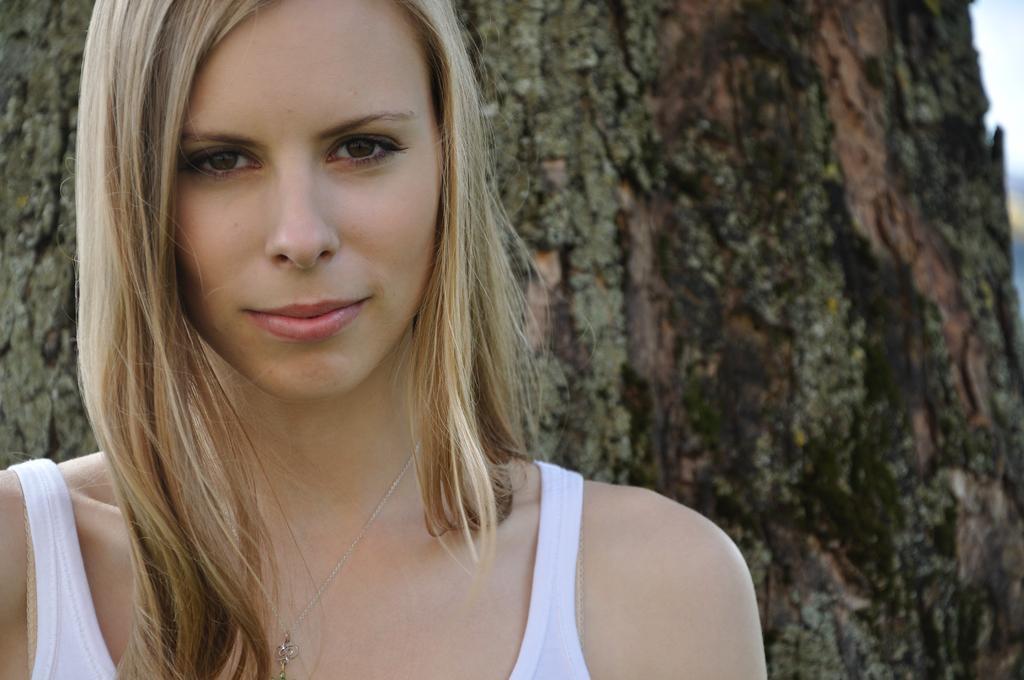Please provide a concise description of this image. This image is taken outdoors. In the background there is a tree. On the left side of the image there is a woman and she is with a smiling face. 